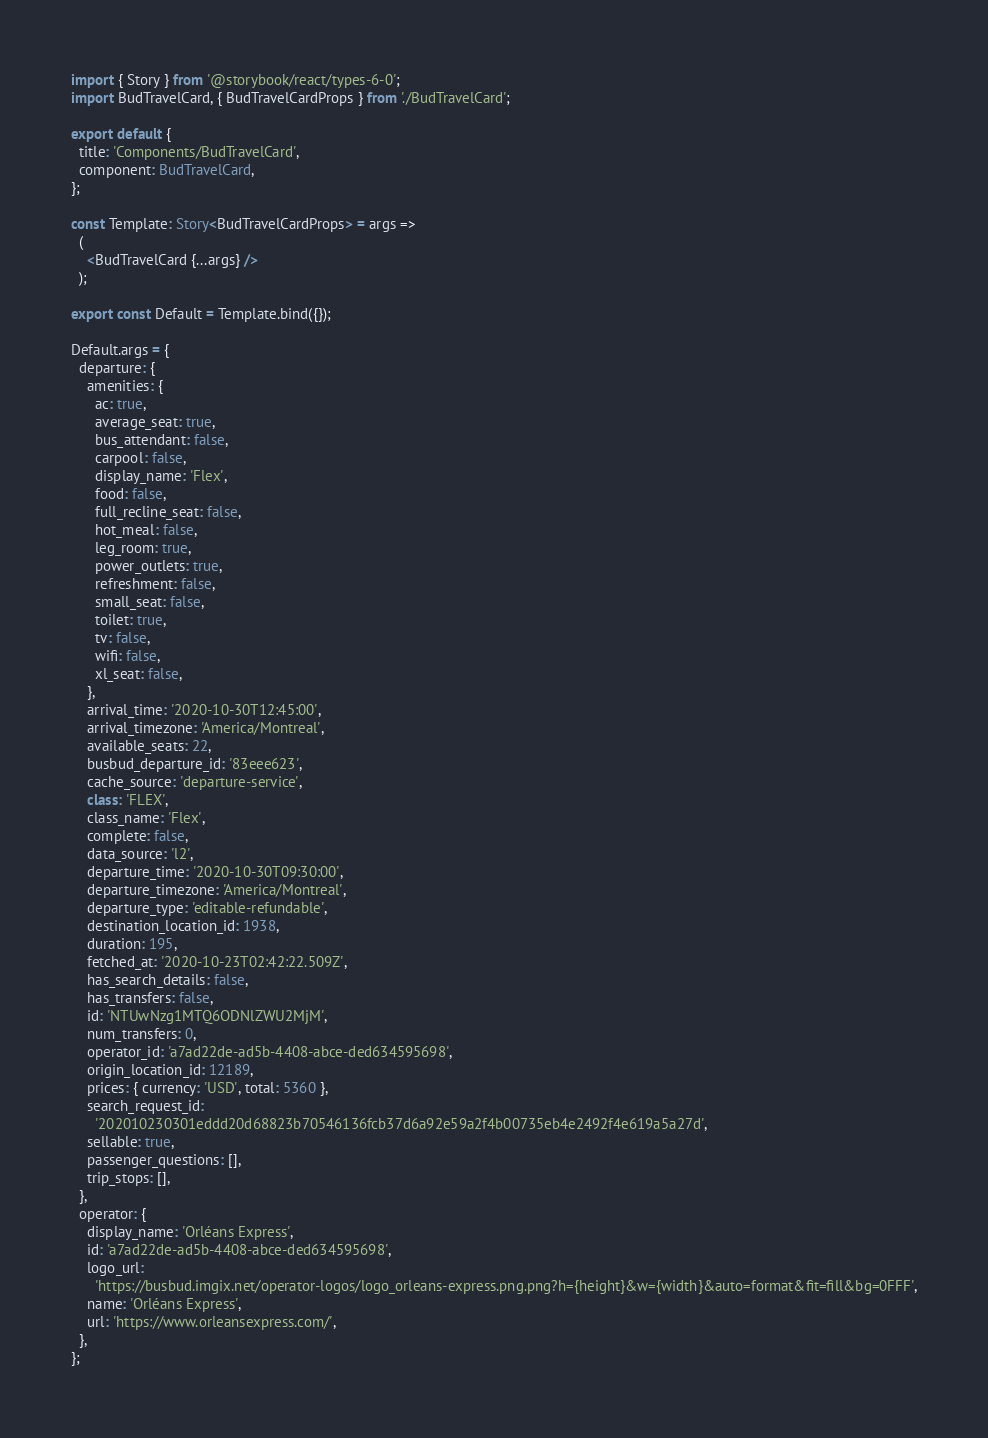Convert code to text. <code><loc_0><loc_0><loc_500><loc_500><_TypeScript_>import { Story } from '@storybook/react/types-6-0';
import BudTravelCard, { BudTravelCardProps } from './BudTravelCard';

export default {
  title: 'Components/BudTravelCard',
  component: BudTravelCard,
};

const Template: Story<BudTravelCardProps> = args =>
  (
    <BudTravelCard {...args} />
  );

export const Default = Template.bind({});

Default.args = {
  departure: {
    amenities: {
      ac: true,
      average_seat: true,
      bus_attendant: false,
      carpool: false,
      display_name: 'Flex',
      food: false,
      full_recline_seat: false,
      hot_meal: false,
      leg_room: true,
      power_outlets: true,
      refreshment: false,
      small_seat: false,
      toilet: true,
      tv: false,
      wifi: false,
      xl_seat: false,
    },
    arrival_time: '2020-10-30T12:45:00',
    arrival_timezone: 'America/Montreal',
    available_seats: 22,
    busbud_departure_id: '83eee623',
    cache_source: 'departure-service',
    class: 'FLEX',
    class_name: 'Flex',
    complete: false,
    data_source: 'l2',
    departure_time: '2020-10-30T09:30:00',
    departure_timezone: 'America/Montreal',
    departure_type: 'editable-refundable',
    destination_location_id: 1938,
    duration: 195,
    fetched_at: '2020-10-23T02:42:22.509Z',
    has_search_details: false,
    has_transfers: false,
    id: 'NTUwNzg1MTQ6ODNlZWU2MjM',
    num_transfers: 0,
    operator_id: 'a7ad22de-ad5b-4408-abce-ded634595698',
    origin_location_id: 12189,
    prices: { currency: 'USD', total: 5360 },
    search_request_id:
      '202010230301eddd20d68823b70546136fcb37d6a92e59a2f4b00735eb4e2492f4e619a5a27d',
    sellable: true,
    passenger_questions: [],
    trip_stops: [],
  },
  operator: {
    display_name: 'Orléans Express',
    id: 'a7ad22de-ad5b-4408-abce-ded634595698',
    logo_url:
      'https://busbud.imgix.net/operator-logos/logo_orleans-express.png.png?h={height}&w={width}&auto=format&fit=fill&bg=0FFF',
    name: 'Orléans Express',
    url: 'https://www.orleansexpress.com/',
  },
};
</code> 